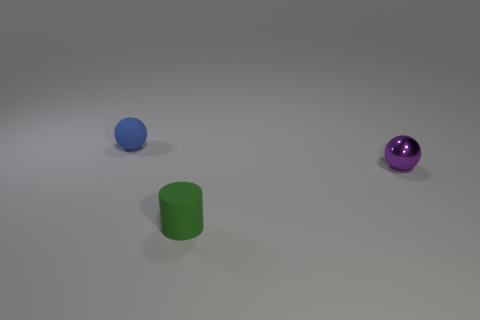Add 1 big cyan cylinders. How many objects exist? 4 Subtract all cylinders. How many objects are left? 2 Subtract 0 cyan spheres. How many objects are left? 3 Subtract all tiny blocks. Subtract all small balls. How many objects are left? 1 Add 3 small matte spheres. How many small matte spheres are left? 4 Add 1 small matte cubes. How many small matte cubes exist? 1 